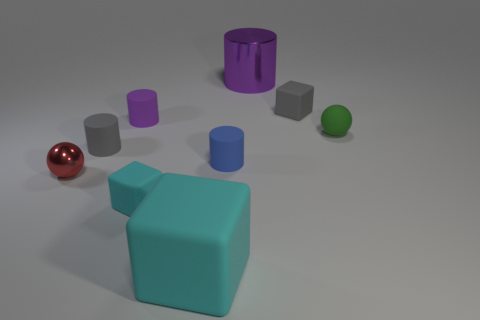Subtract all blue cylinders. Subtract all purple blocks. How many cylinders are left? 3 Add 1 big cyan cubes. How many objects exist? 10 Subtract all blocks. How many objects are left? 6 Subtract 0 yellow blocks. How many objects are left? 9 Subtract all blue matte things. Subtract all small cyan objects. How many objects are left? 7 Add 8 tiny gray rubber cylinders. How many tiny gray rubber cylinders are left? 9 Add 7 tiny gray balls. How many tiny gray balls exist? 7 